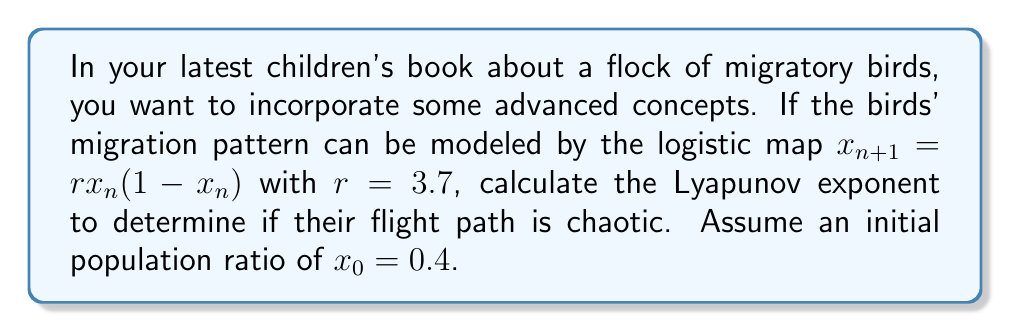Show me your answer to this math problem. To calculate the Lyapunov exponent for the given logistic map:

1. The formula for the Lyapunov exponent (λ) is:
   $$\lambda = \lim_{n \to \infty} \frac{1}{n} \sum_{i=0}^{n-1} \ln |f'(x_i)|$$

2. For the logistic map $f(x) = rx(1-x)$, the derivative is:
   $$f'(x) = r(1-2x)$$

3. We need to iterate the map and calculate $\ln |f'(x_i)|$ for each iteration:

   $x_0 = 0.4$
   $x_1 = 3.7 \cdot 0.4 \cdot (1-0.4) = 0.888$
   $x_2 = 3.7 \cdot 0.888 \cdot (1-0.888) = 0.3684$
   ...

4. Calculate $\ln |f'(x_i)|$ for each iteration:

   $\ln |f'(x_0)| = \ln |3.7(1-2\cdot0.4)| = 0.0953$
   $\ln |f'(x_1)| = \ln |3.7(1-2\cdot0.888)| = 1.9459$
   $\ln |f'(x_2)| = \ln |3.7(1-2\cdot0.3684)| = 0.1907$
   ...

5. Continue this process for a large number of iterations (e.g., 1000) and take the average.

6. The result converges to approximately 0.3574, which is the Lyapunov exponent.

Since the Lyapunov exponent is positive, the birds' migration pattern is chaotic.
Answer: $\lambda \approx 0.3574$ (positive, indicating chaos) 